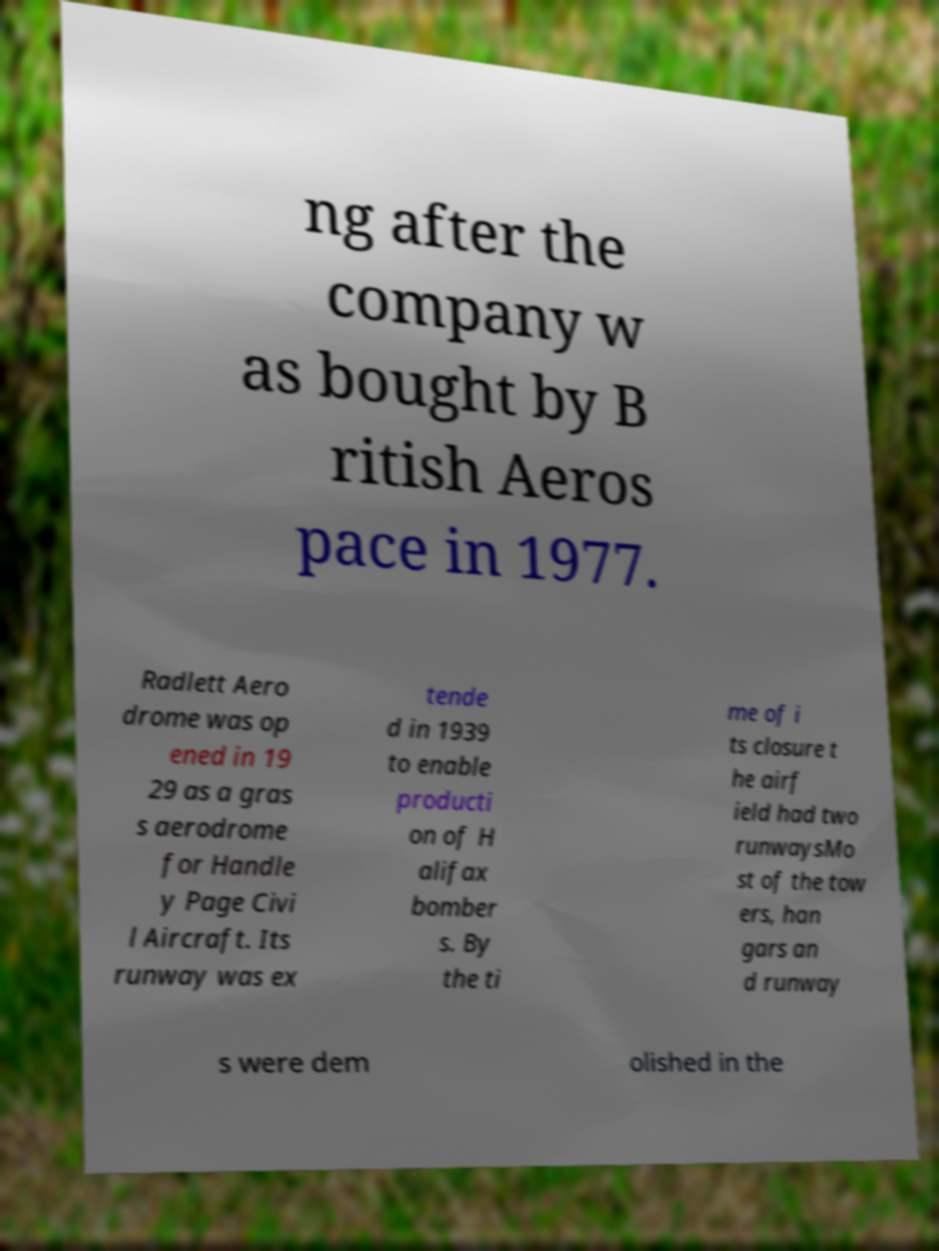Could you assist in decoding the text presented in this image and type it out clearly? ng after the company w as bought by B ritish Aeros pace in 1977. Radlett Aero drome was op ened in 19 29 as a gras s aerodrome for Handle y Page Civi l Aircraft. Its runway was ex tende d in 1939 to enable producti on of H alifax bomber s. By the ti me of i ts closure t he airf ield had two runwaysMo st of the tow ers, han gars an d runway s were dem olished in the 